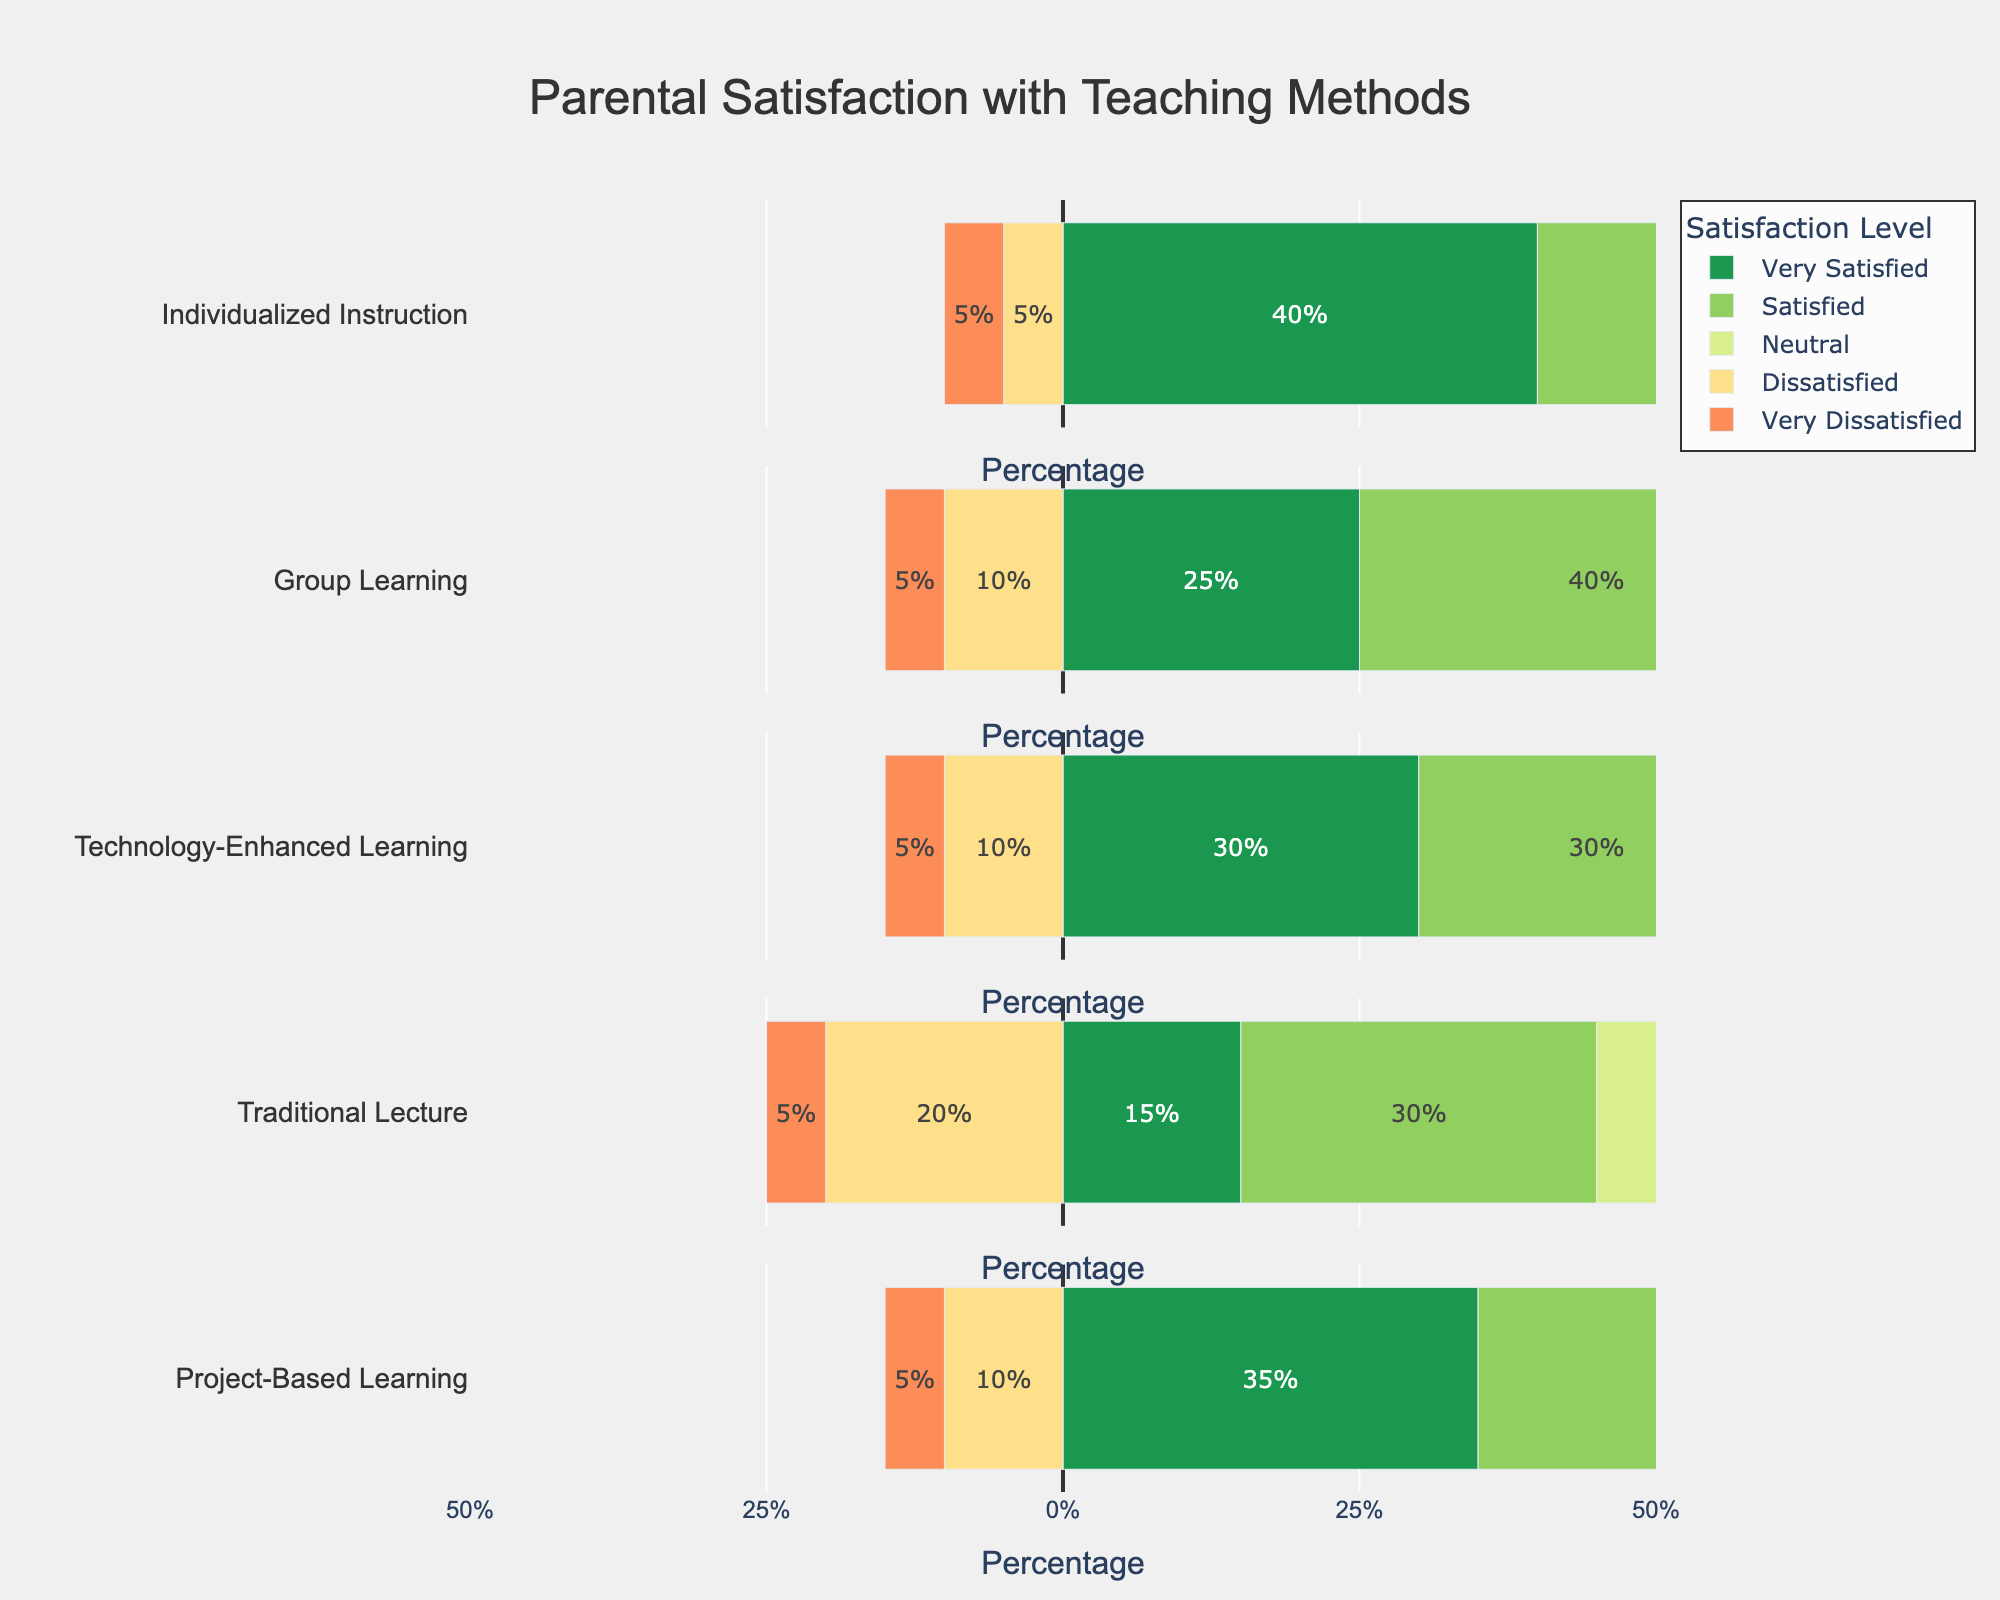Which teaching method has the highest percentage of parents who are "Very Satisfied"? By inspecting the length of the green bars, we can see that "Individualized Instruction" has the highest percentage at 40%.
Answer: Individualized Instruction Which teaching method has the least percentage of parents who are "Very Dissatisfied"? By comparing the lengths of the red bars, each method has the same percentage of 5%. But since the comparable percentage is equal across methods, select "Individualized Instruction" as a representative method.
Answer: Individualized Instruction What is the total percentage of parents who are either "Very Satisfied" or "Satisfied" with Group Learning? Add the lengths of the green and light green bars for Group Learning: 25% (Very Satisfied) + 40% (Satisfied) = 65%.
Answer: 65% How does the satisfaction level for "Very Satisfied" compare between "Traditional Lecture" and "Project-Based Learning"? The length of the green bar for "Traditional Lecture" is 15%, while for "Project-Based Learning" it is 35%. Therefore, "Project-Based Learning" has a higher percentage.
Answer: Project-Based Learning What is the percentage difference in "Neutral" satisfaction level between "Technology-Enhanced Learning" and "Traditional Lecture"? The length of the yellow bar is 25% for "Technology-Enhanced Learning" and 30% for "Traditional Lecture". The difference is 30% - 25% = 5%.
Answer: 5% Which teaching method has the highest combined dissatisfaction percentage ("Dissatisfied" + "Very Dissatisfied")? First calculate the combined dissatisfaction percentage for each method:
- Individualized Instruction: 5% (Dissatisfied) + 5% (Very Dissatisfied) = 10%
- Group Learning: 10% + 5% = 15%
- Technology-Enhanced Learning: 10% + 5% = 15%
- Traditional Lecture: 20% + 5% = 25%
- Project-Based Learning: 10% + 5% = 15%
"Traditional Lecture" has the highest combined dissatisfaction at 25%.
Answer: Traditional Lecture What is the combined percentage of parents who are "Satisfied" with either "Individualized Instruction" or "Project-Based Learning"? Add the lengths of the light green bars: 35% (Individualized Instruction) + 35% (Project-Based Learning) = 70%.
Answer: 70% For which teaching method is the "Neutral" satisfaction level the highest? Comparing the lengths of the yellow bars, "Traditional Lecture" and "Technology-Enhanced Learning" have the highest percentage, both at 30%.
Answer: Traditional Lecture and Technology-Enhanced Learning To which satisfaction level should "Project-Based Learning"'s "Satisfied" percentage be added to match or exceed "Individualized Instruction's" "Very Satisfied" percentage? "Project-Based Learning" has 35% Satisfied, and "Individualized Instruction" has 40% Very Satisfied. Adding "Satisfied" (35%) to any other level to match 40%:
Find another level's percentage that adds to 35% to make it 40%, thus;
35% (Satisfied) + 5% (Very Dissatisfied or Dissatisfied or Neutral) >= 40%.
Answer: Any level with 5% 